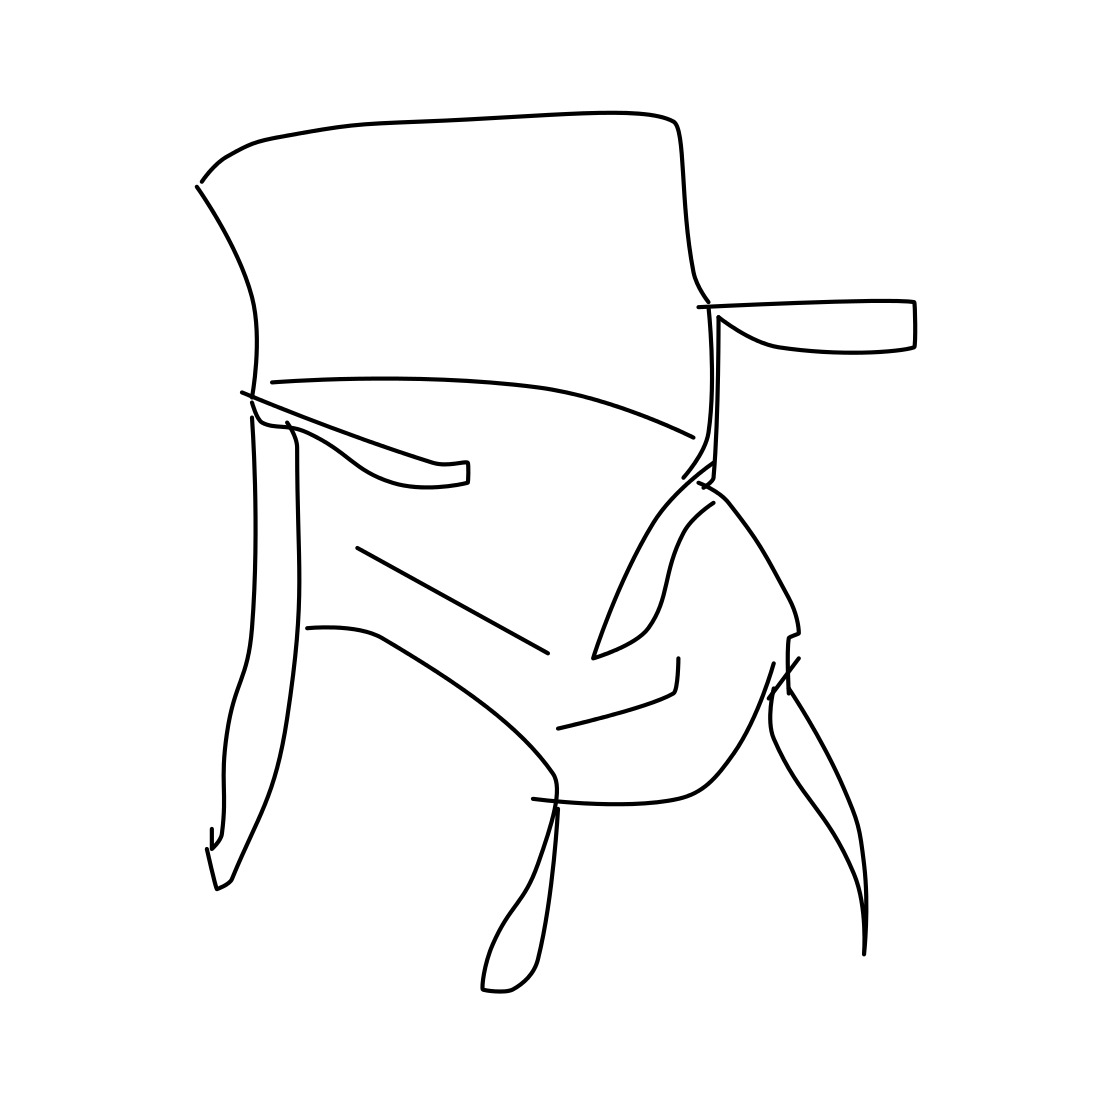What artistic style is represented in this image? This image represents a minimalist and abstract artistic style, focusing on simplicity and the use of clean lines to suggest a form. What could the image represent? The image may represent a chair, given its structure, but it could also be open to interpretation as other objects or as a purely abstract design. 